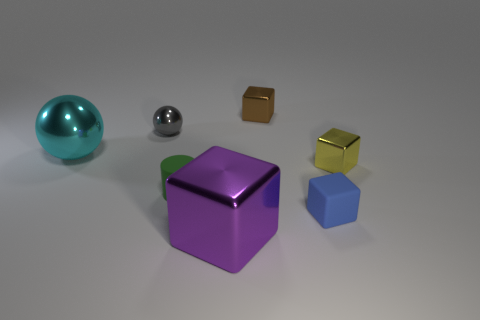What number of green matte objects are left of the blue rubber cube?
Your answer should be compact. 1. Are there the same number of yellow metal blocks that are behind the yellow object and yellow metal things behind the big cube?
Keep it short and to the point. No. What is the size of the purple metallic object that is the same shape as the blue object?
Keep it short and to the point. Large. The rubber thing right of the big cube has what shape?
Keep it short and to the point. Cube. Is the material of the block that is to the left of the tiny brown metallic thing the same as the cube behind the small yellow metallic block?
Provide a short and direct response. Yes. The small blue matte object has what shape?
Offer a terse response. Cube. Are there an equal number of cyan balls behind the rubber cube and blue objects?
Provide a succinct answer. Yes. Is there a cylinder made of the same material as the small yellow thing?
Your answer should be compact. No. Do the tiny metal thing that is in front of the small gray shiny object and the large metallic object that is in front of the blue matte block have the same shape?
Your response must be concise. Yes. Are any blue cylinders visible?
Your response must be concise. No. 